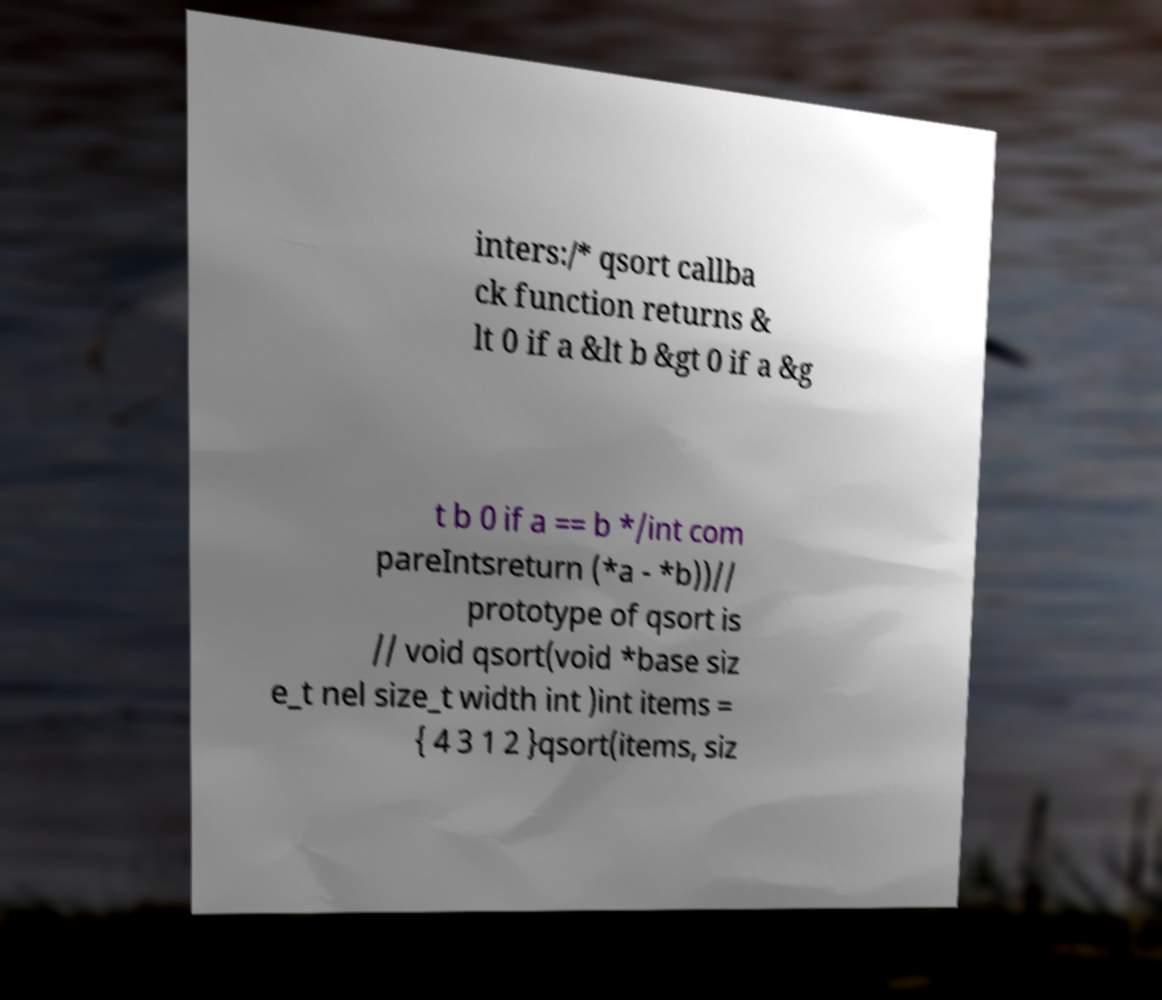Please identify and transcribe the text found in this image. inters:/* qsort callba ck function returns & lt 0 if a &lt b &gt 0 if a &g t b 0 if a == b */int com pareIntsreturn (*a - *b))// prototype of qsort is // void qsort(void *base siz e_t nel size_t width int )int items = { 4 3 1 2 }qsort(items, siz 